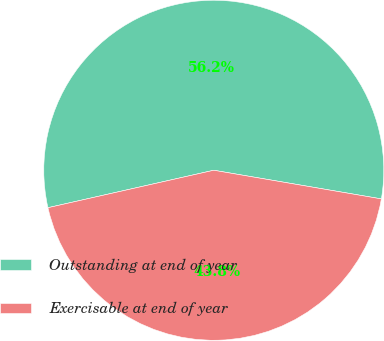Convert chart to OTSL. <chart><loc_0><loc_0><loc_500><loc_500><pie_chart><fcel>Outstanding at end of year<fcel>Exercisable at end of year<nl><fcel>56.23%<fcel>43.77%<nl></chart> 